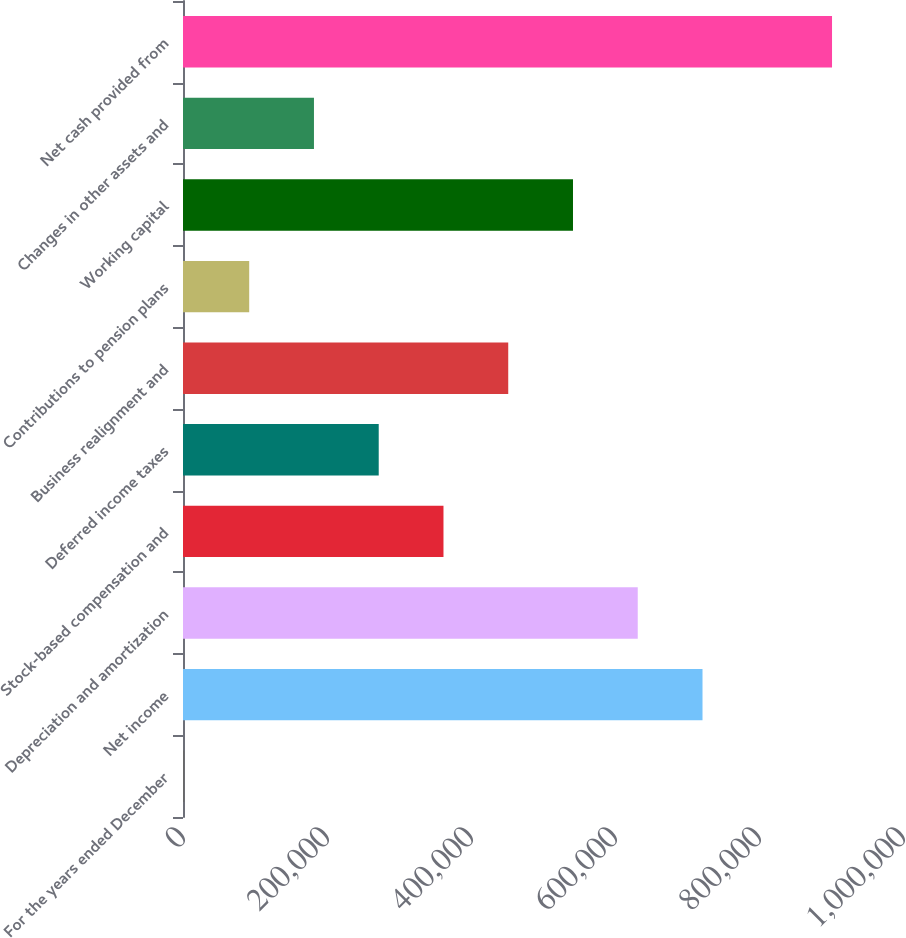Convert chart to OTSL. <chart><loc_0><loc_0><loc_500><loc_500><bar_chart><fcel>For the years ended December<fcel>Net income<fcel>Depreciation and amortization<fcel>Stock-based compensation and<fcel>Deferred income taxes<fcel>Business realignment and<fcel>Contributions to pension plans<fcel>Working capital<fcel>Changes in other assets and<fcel>Net cash provided from<nl><fcel>2010<fcel>721540<fcel>631599<fcel>361775<fcel>271834<fcel>451716<fcel>91951.3<fcel>541658<fcel>181893<fcel>901423<nl></chart> 